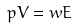Convert formula to latex. <formula><loc_0><loc_0><loc_500><loc_500>p V = w E</formula> 